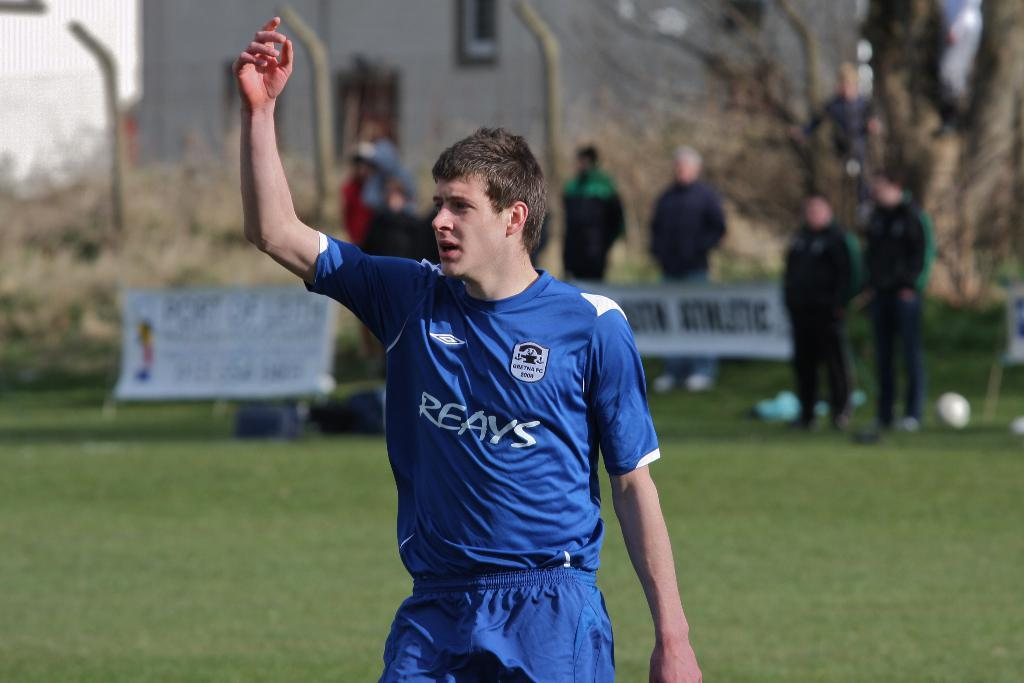<image>
Write a terse but informative summary of the picture. the boy wearing a REAYS jersey is raising his right hand 